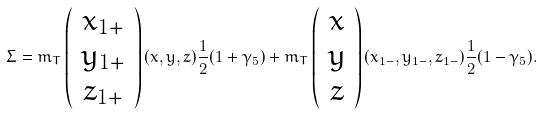<formula> <loc_0><loc_0><loc_500><loc_500>\Sigma = m _ { T } \left ( \begin{array} { c } x _ { 1 + } \\ y _ { 1 + } \\ z _ { 1 + } \end{array} \right ) ( x , y , z ) \frac { 1 } { 2 } ( 1 + \gamma _ { 5 } ) + m _ { T } \left ( \begin{array} { c } x \\ y \\ z \end{array} \right ) ( x _ { 1 - } , y _ { 1 - } , z _ { 1 - } ) \frac { 1 } { 2 } ( 1 - \gamma _ { 5 } ) .</formula> 